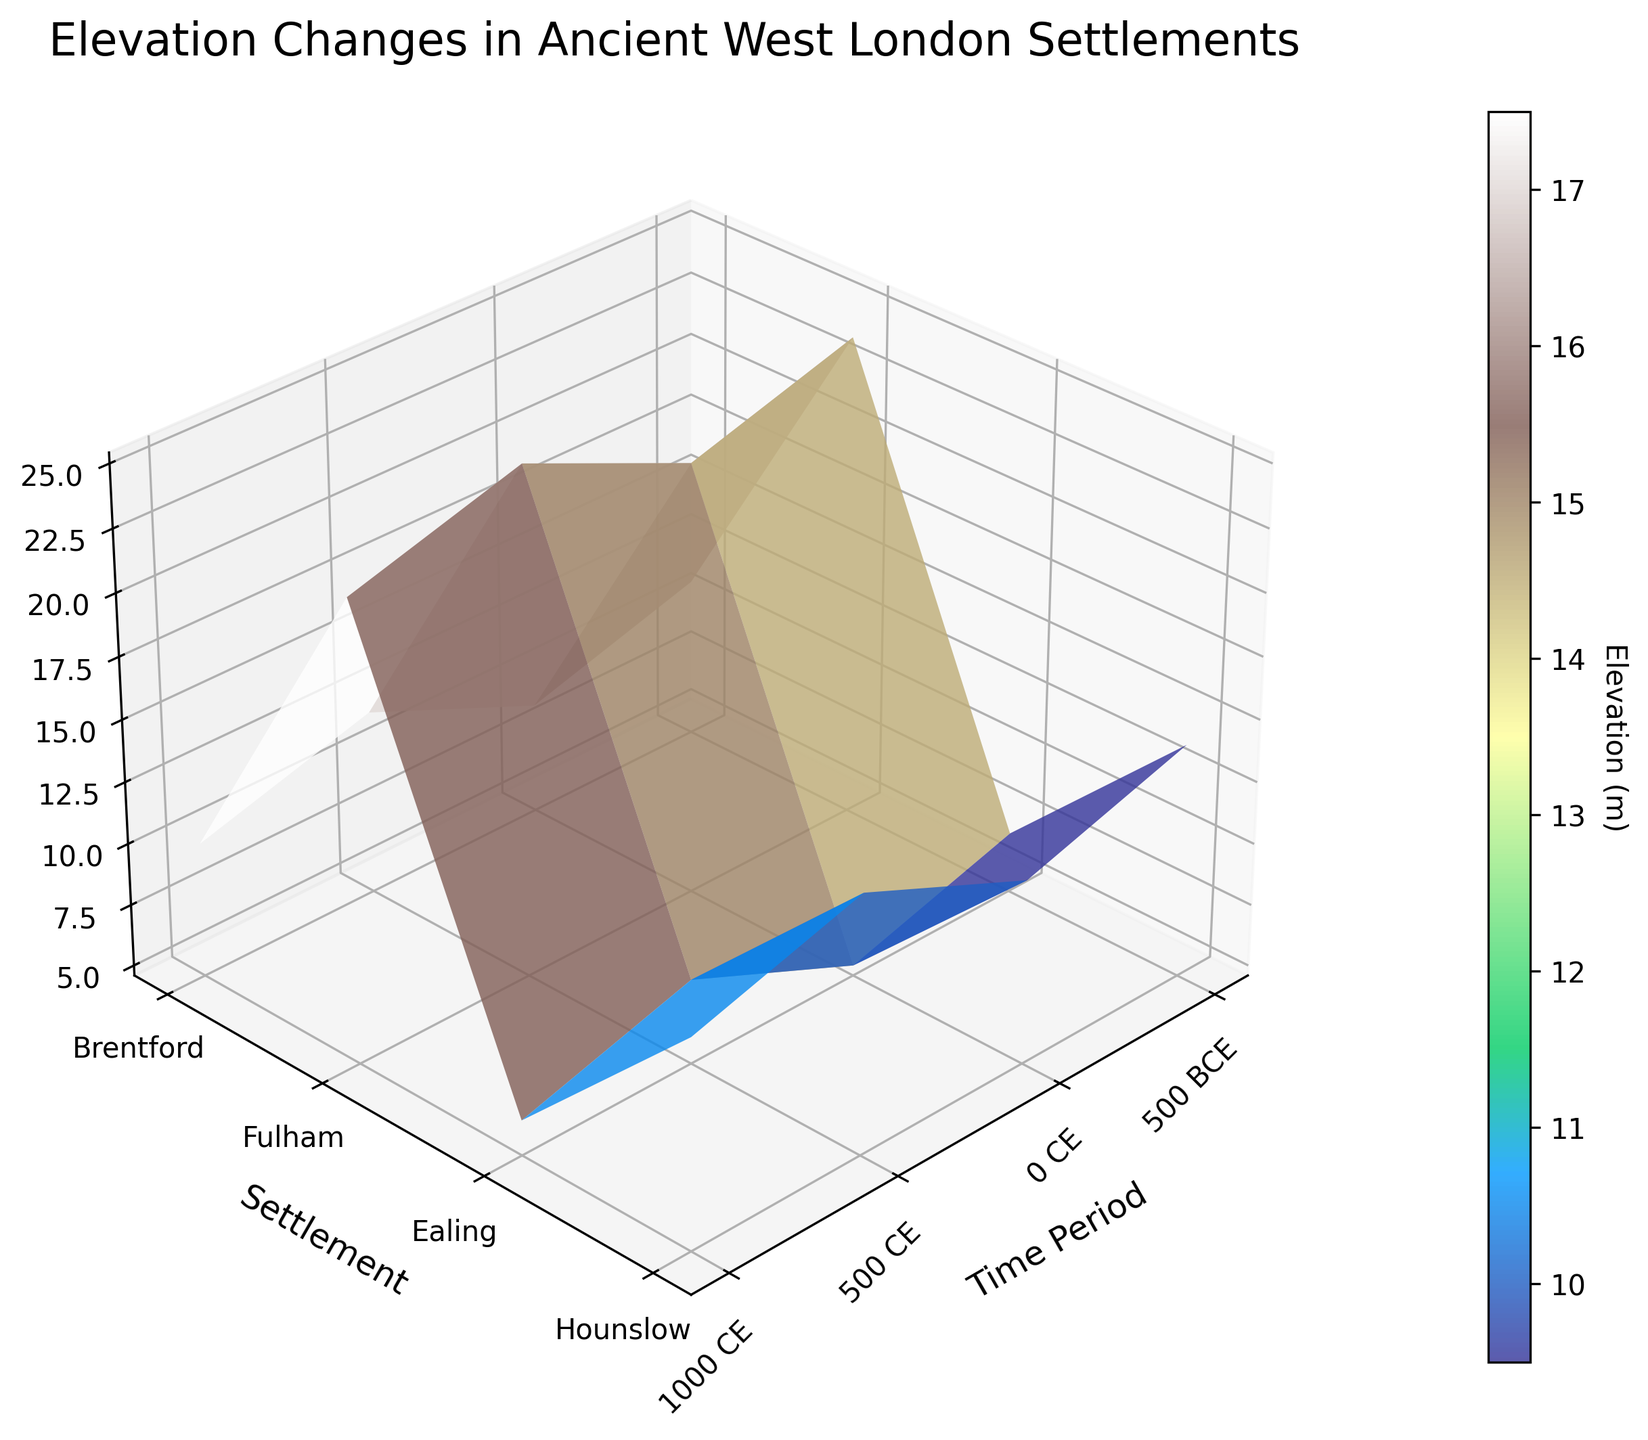What is the title of the figure? The title of the plot is displayed at the top, centered, and it describes what the plot is about. The title reads "Elevation Changes in Ancient West London Settlements".
Answer: Elevation Changes in Ancient West London Settlements Which time period had the highest elevation in Ealing? By examining the vertical axis corresponding to 'Ealing' and following it to identify the peak, the highest elevation for Ealing is found at the 500 BCE time period.
Answer: 500 BCE Compare the elevation of Hounslow between 500 BCE and 0 CE. Which is higher? By observing the values on the vertical axis for Hounslow at both 500 BCE and 0 CE, it can be seen that the elevation at 500 BCE is 15 meters, and at 0 CE is 14 meters. Therefore, 500 BCE has a higher elevation.
Answer: 500 BCE Which settlement witnessed the greatest decline in elevation over the recorded time periods? By inspecting the elevation changes over time for each settlement, Brentford shows a drop from 12 meters at 500 BCE to 9 meters at 1000 CE, a decline of 3 meters.
Answer: Brentford What is the overall trend in the elevation of Fulham from 500 BCE to 1000 CE? Observing the elevation of Fulham at each time period: 8 meters at 500 BCE, 7 meters at 0 CE, 6 meters at 500 CE, and 5 meters at 1000 CE, it shows a consistent decline over time.
Answer: Decline How many time periods are represented on the plot? The x-axis of the plot shows the distinct time periods. By counting the labels on the x-axis, we note there are four time periods: 500 BCE, 0 CE, 500 CE, and 1000 CE.
Answer: Four Which settlement had the least variation in elevation over time? By comparing the range of elevations for each settlement across the time periods, Ealing had the least variation with a drop from 25 meters at 500 BCE to 22 meters at 1000 CE, only varying by 3 meters.
Answer: Ealing What is the color used for the highest elevation on the plot? The color corresponding to the highest elevation, based on the color bar and elevation in Ealing at 500 BCE, is a shade of green.
Answer: Green Determine the elevation difference between Brentford and Hounslow at 500 CE. The elevation at 500 CE for Brentford is 10 meters and for Hounslow is 13 meters. The difference is 13 - 10 = 3 meters.
Answer: 3 meters How did the elevation of all the settlements change from 0 CE to 500 CE? Observing each settlement's elevation: Brentford decreased from 11 m to 10 m, Fulham decreased from 7 m to 6 m, Ealing decreased from 24 m to 23 m, and Hounslow decreased from 14 m to 13 m. All settlements show a decline from 0 CE to 500 CE.
Answer: Decreased 